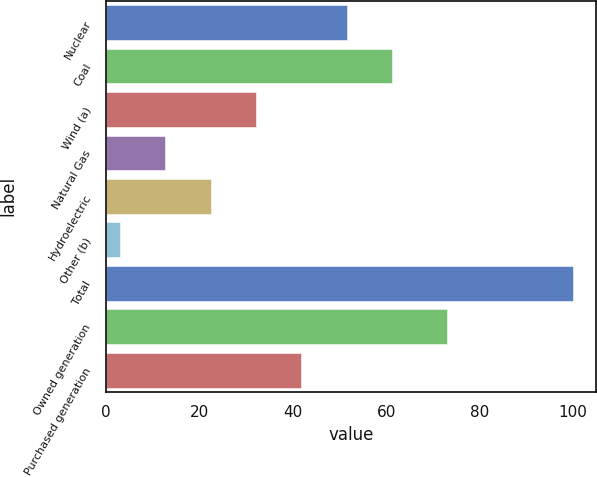<chart> <loc_0><loc_0><loc_500><loc_500><bar_chart><fcel>Nuclear<fcel>Coal<fcel>Wind (a)<fcel>Natural Gas<fcel>Hydroelectric<fcel>Other (b)<fcel>Total<fcel>Owned generation<fcel>Purchased generation<nl><fcel>51.5<fcel>61.2<fcel>32.1<fcel>12.7<fcel>22.4<fcel>3<fcel>100<fcel>73<fcel>41.8<nl></chart> 